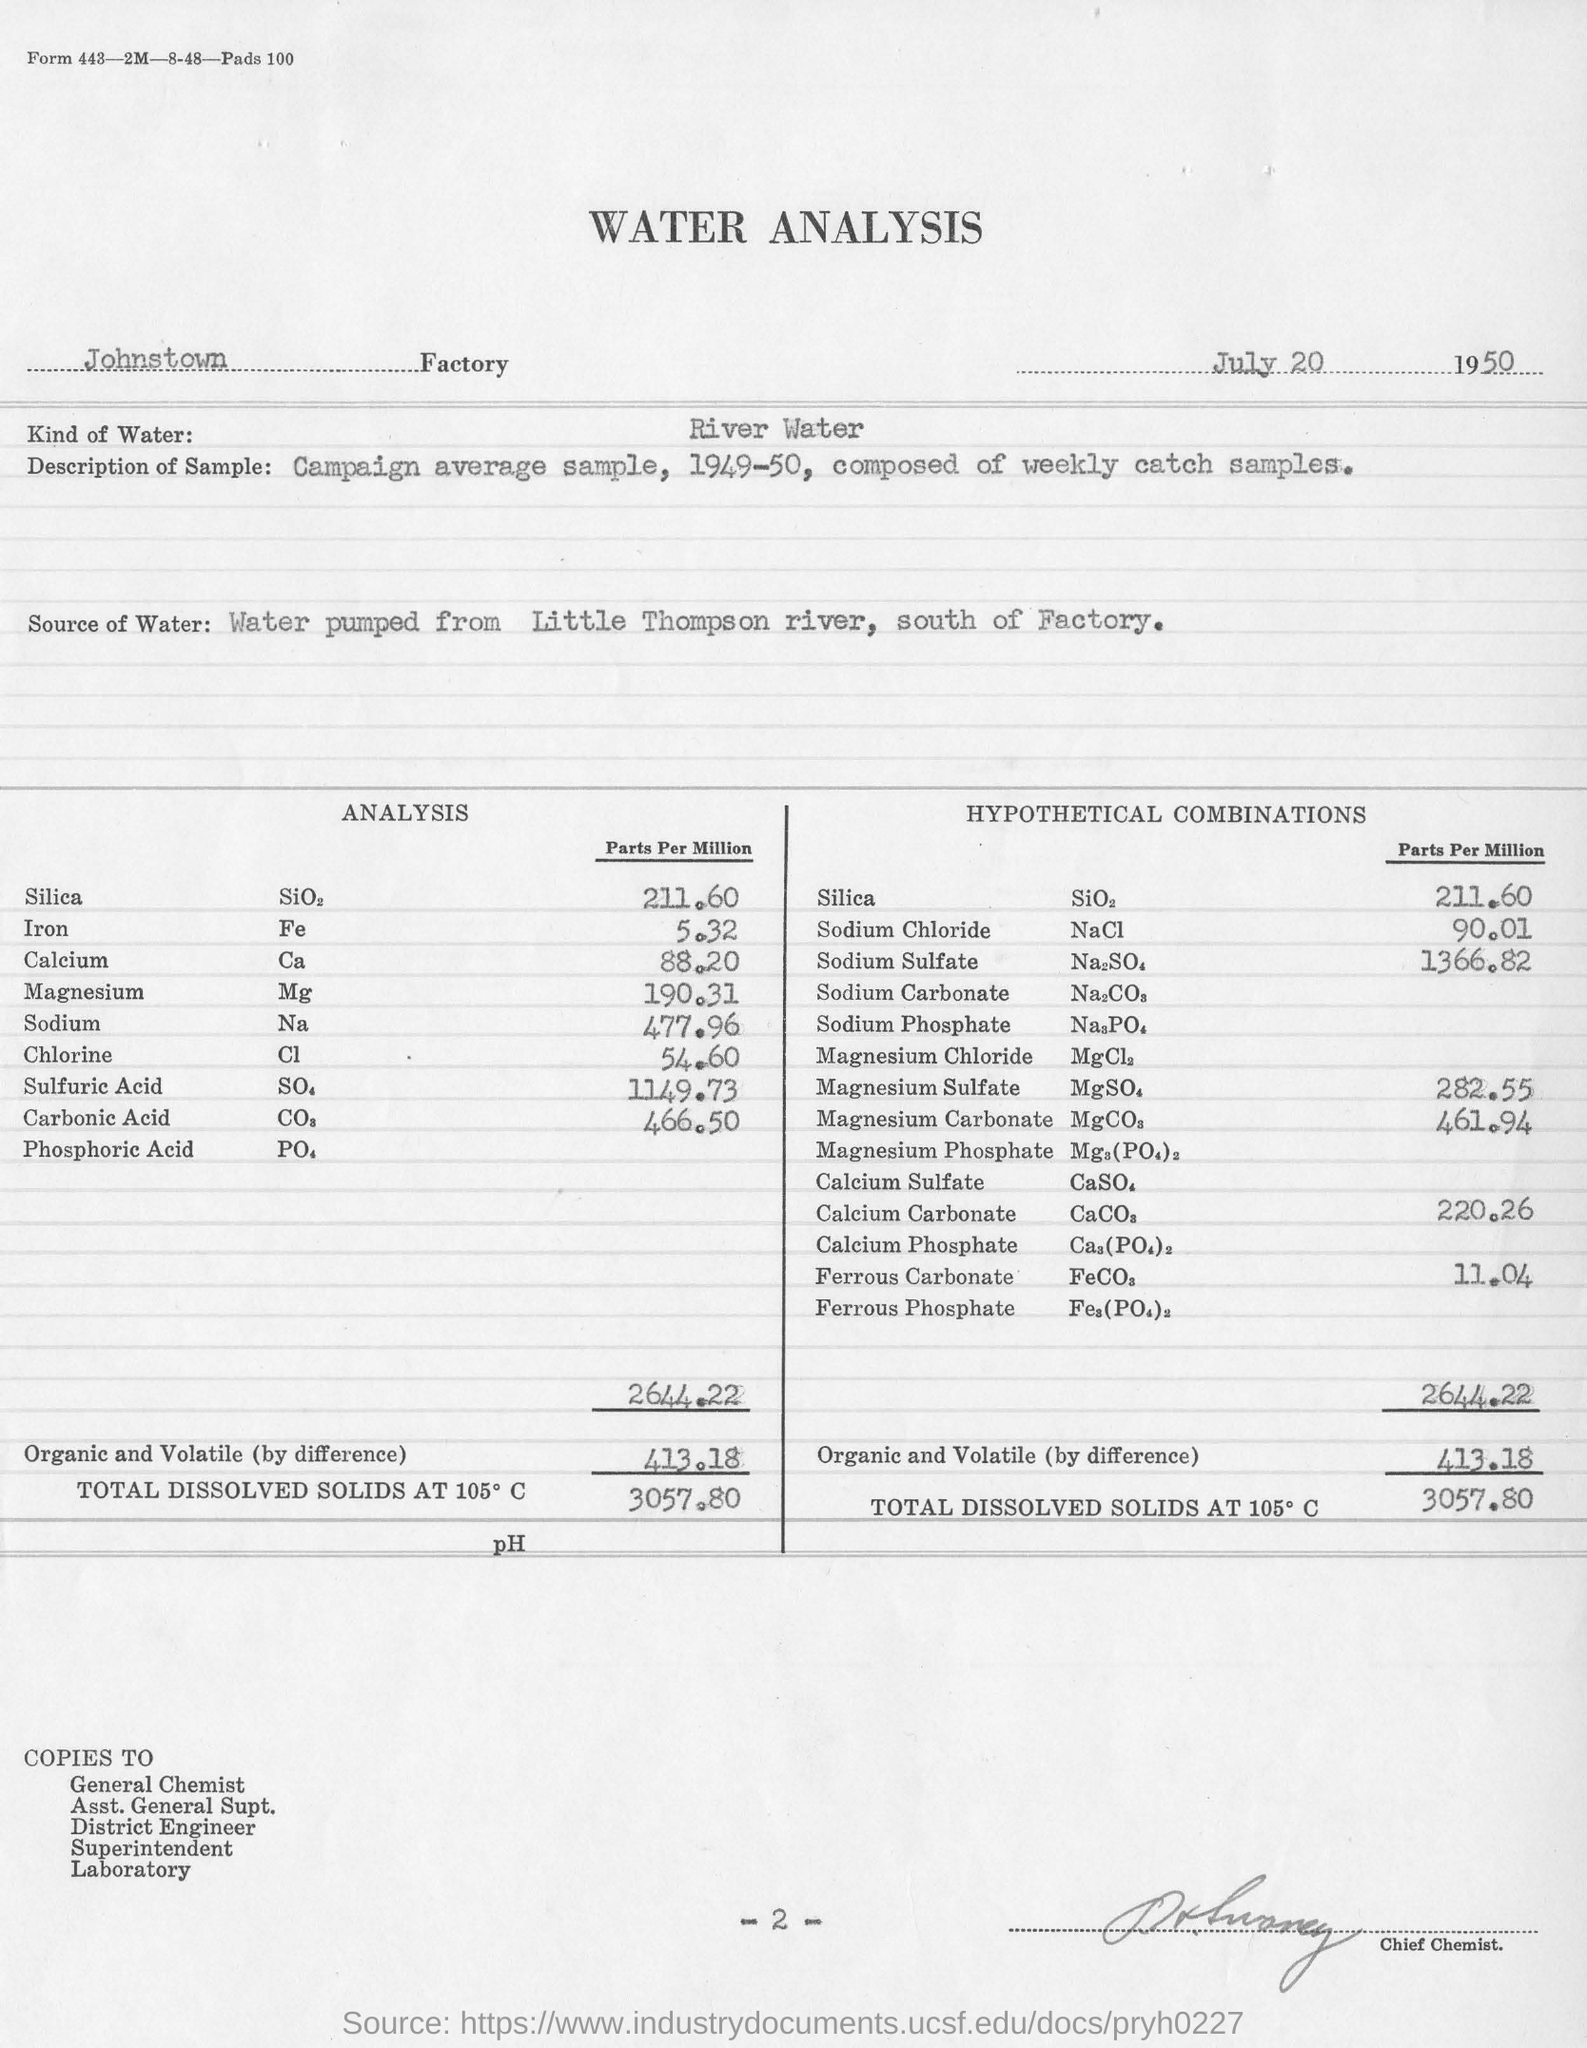Specify some key components in this picture. The water was river water. According to the analysis, the total dissolved solids at 105°C were found to be 3057.80... The Johnstown Factory is mentioned. The water analysis was dated July 20, 1950. Water was pumped from the Little Thompson river. 